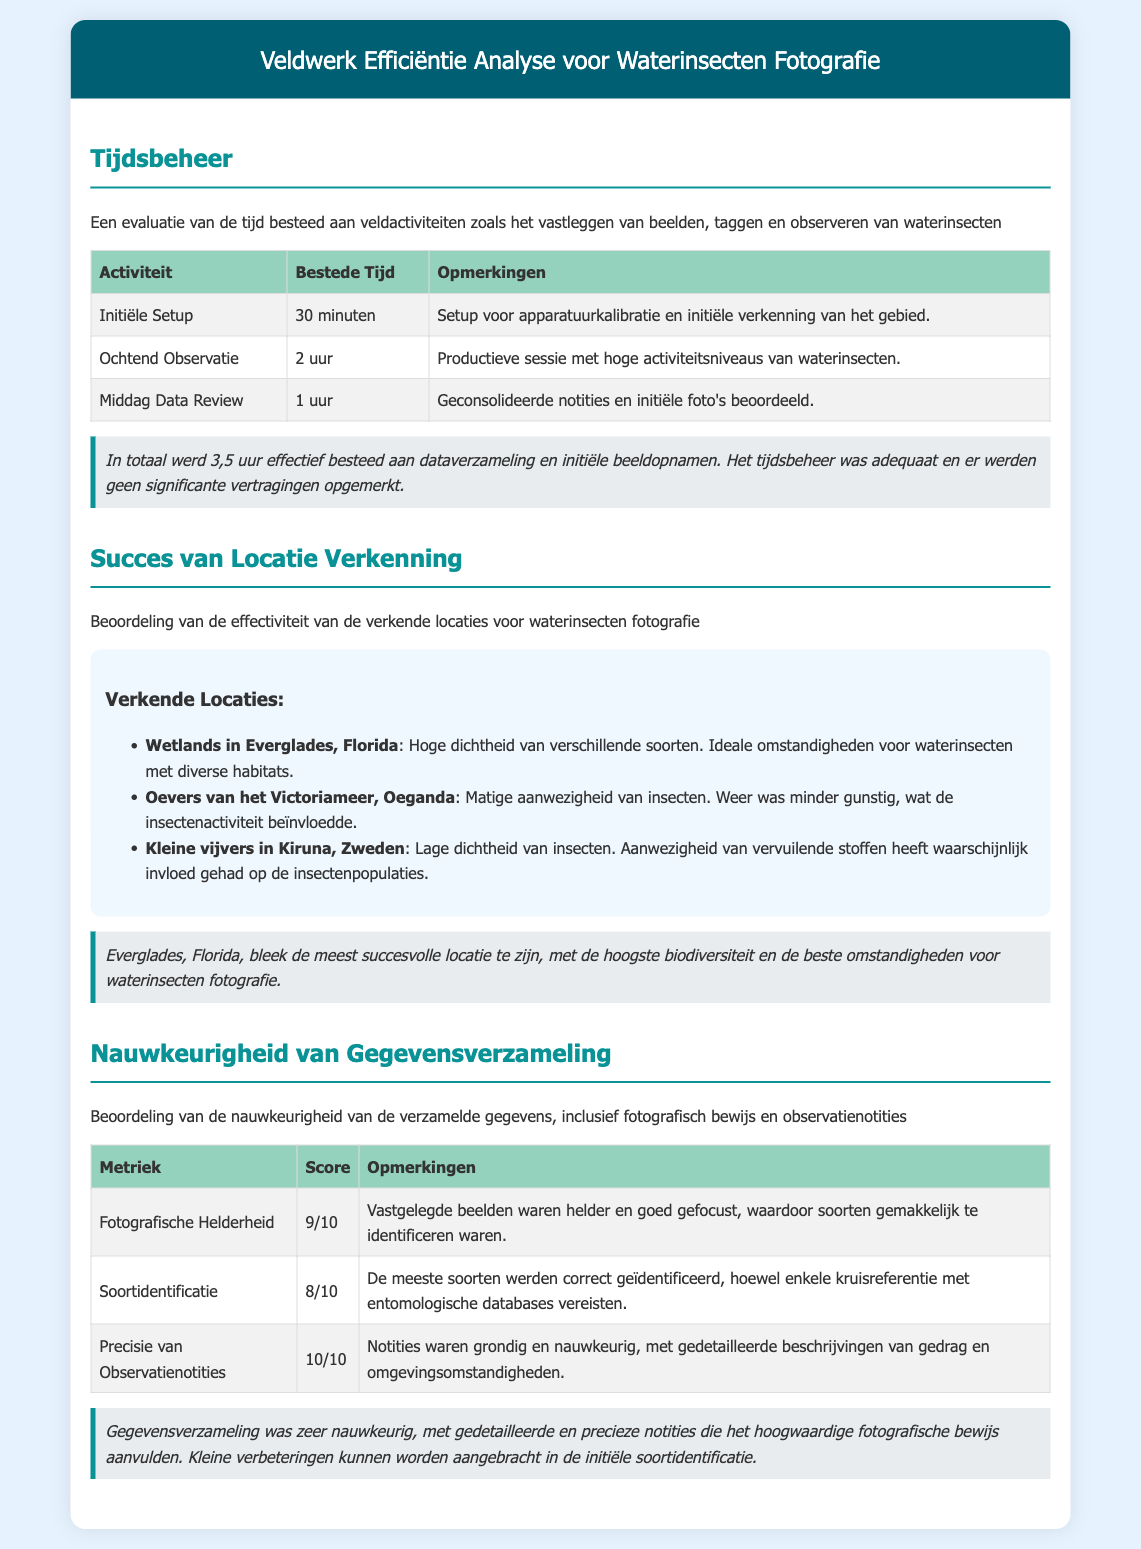Wat is de totale tijd besteed aan dataverzameling? De totale tijd besteed aan dataverzameling is de som van alle bestede tijden in de tabel, namelijk 30 minuten plus 2 uur plus 1 uur, wat in totaal 3,5 uur maakt.
Answer: 3,5 uur Wat was de score voor fotografische helderheid? De score voor fotografische helderheid is directe informatie vermeld in de tabel van de nauwkeurigheid van gegevensverzameling.
Answer: 9/10 Welke locatie had de hoogste biodiversiteit? De locatie met de hoogste biodiversiteit wordt beschreven als de meest succesvolle locatie in de sectie over locatie verkenning.
Answer: Everglades, Florida Wat waren de notities voorzien van observaties? De precisie van observatienotities is gegeven in de tabel onder de sectie 'Nauwkeurigheid van Gegevensverzameling'.
Answer: 10/10 Hoeveel minuten werden besteed aan de initiële setup? De initiële setup tijd is specifiek vermeld in de tabel met tijdsbeheer waar 30 minuten staat genoteerd.
Answer: 30 minuten Welke plaats had een lage dichtheid van insecten? Deze informatie komt uit de sectie over succesvolle locatieverkenning waar de lage dichtheid van insecten wordt genoemd.
Answer: Kleine vijvers in Kiruna, Zweden Wat is de totale tijd voor de ochtendobservatie? De tijd voor de ochtendobservatie staat in de tabel onder tijdsbeheer en is 2 uur.
Answer: 2 uur Wat is de belangrijkste opmerking over de middag data review? De belangrijkste opmerking over de middag data review wordt genoemd in de tabel met een korte beschrijving.
Answer: Geconsolideerde notities en initiële foto's beoordeeld 